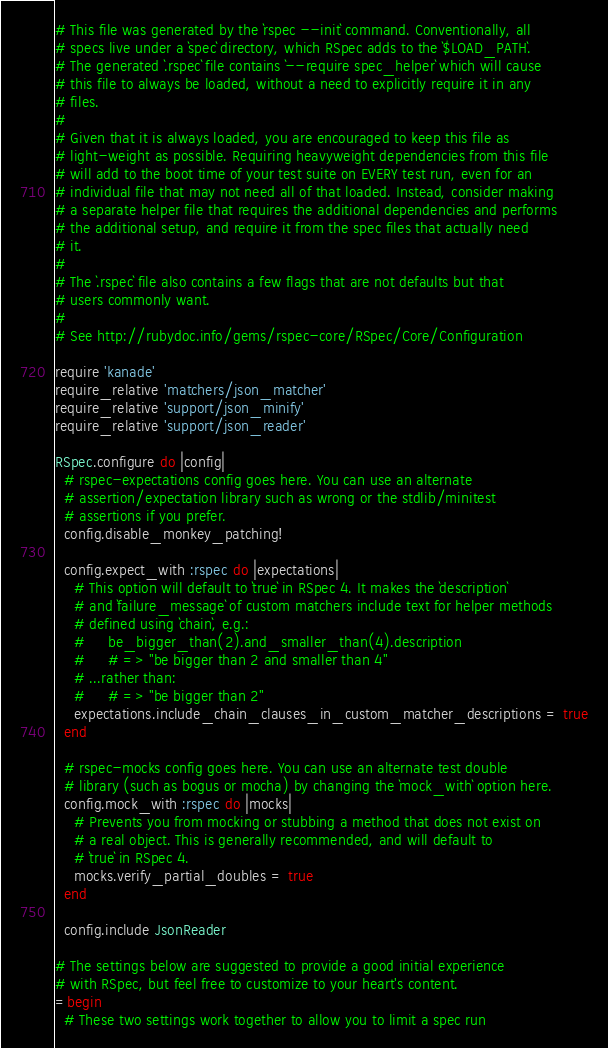<code> <loc_0><loc_0><loc_500><loc_500><_Ruby_># This file was generated by the `rspec --init` command. Conventionally, all
# specs live under a `spec` directory, which RSpec adds to the `$LOAD_PATH`.
# The generated `.rspec` file contains `--require spec_helper` which will cause
# this file to always be loaded, without a need to explicitly require it in any
# files.
#
# Given that it is always loaded, you are encouraged to keep this file as
# light-weight as possible. Requiring heavyweight dependencies from this file
# will add to the boot time of your test suite on EVERY test run, even for an
# individual file that may not need all of that loaded. Instead, consider making
# a separate helper file that requires the additional dependencies and performs
# the additional setup, and require it from the spec files that actually need
# it.
#
# The `.rspec` file also contains a few flags that are not defaults but that
# users commonly want.
#
# See http://rubydoc.info/gems/rspec-core/RSpec/Core/Configuration

require 'kanade'
require_relative 'matchers/json_matcher'
require_relative 'support/json_minify'
require_relative 'support/json_reader'

RSpec.configure do |config|
  # rspec-expectations config goes here. You can use an alternate
  # assertion/expectation library such as wrong or the stdlib/minitest
  # assertions if you prefer.
  config.disable_monkey_patching!

  config.expect_with :rspec do |expectations|
    # This option will default to `true` in RSpec 4. It makes the `description`
    # and `failure_message` of custom matchers include text for helper methods
    # defined using `chain`, e.g.:
    #     be_bigger_than(2).and_smaller_than(4).description
    #     # => "be bigger than 2 and smaller than 4"
    # ...rather than:
    #     # => "be bigger than 2"
    expectations.include_chain_clauses_in_custom_matcher_descriptions = true
  end

  # rspec-mocks config goes here. You can use an alternate test double
  # library (such as bogus or mocha) by changing the `mock_with` option here.
  config.mock_with :rspec do |mocks|
    # Prevents you from mocking or stubbing a method that does not exist on
    # a real object. This is generally recommended, and will default to
    # `true` in RSpec 4.
    mocks.verify_partial_doubles = true
  end

  config.include JsonReader

# The settings below are suggested to provide a good initial experience
# with RSpec, but feel free to customize to your heart's content.
=begin
  # These two settings work together to allow you to limit a spec run</code> 